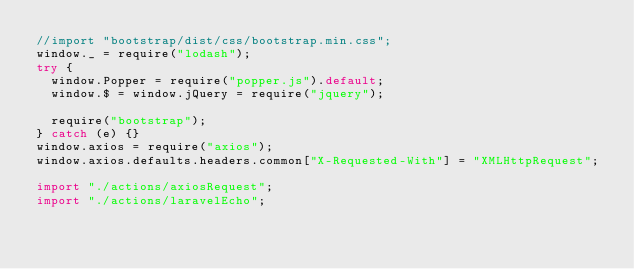Convert code to text. <code><loc_0><loc_0><loc_500><loc_500><_JavaScript_>//import "bootstrap/dist/css/bootstrap.min.css";
window._ = require("lodash");
try {
	window.Popper = require("popper.js").default;
	window.$ = window.jQuery = require("jquery");

	require("bootstrap");
} catch (e) {}
window.axios = require("axios");
window.axios.defaults.headers.common["X-Requested-With"] = "XMLHttpRequest";

import "./actions/axiosRequest";
import "./actions/laravelEcho";
</code> 